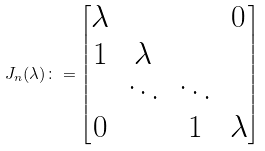<formula> <loc_0><loc_0><loc_500><loc_500>J _ { n } ( \lambda ) \colon = \begin{bmatrix} \lambda & & & 0 \\ 1 & \lambda & & \\ & \ddots & \ddots & \\ 0 & & 1 & \lambda \end{bmatrix}</formula> 